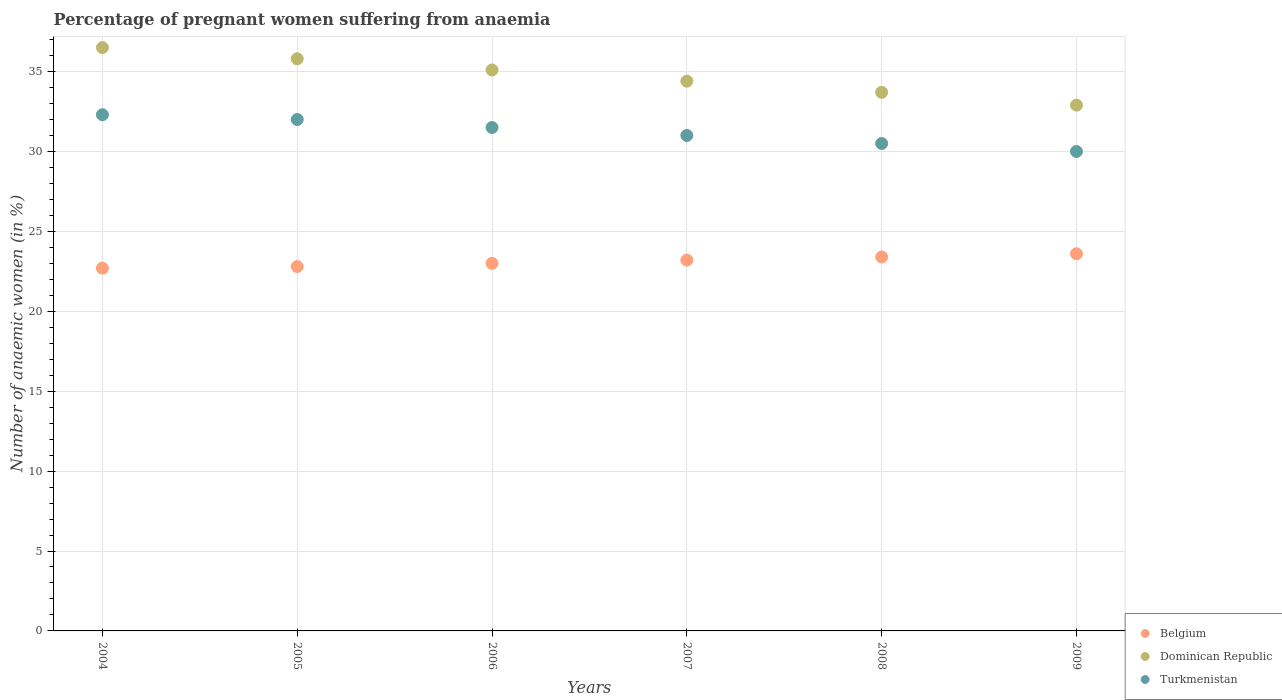How many different coloured dotlines are there?
Provide a succinct answer. 3. Is the number of dotlines equal to the number of legend labels?
Your answer should be very brief. Yes. What is the number of anaemic women in Belgium in 2009?
Ensure brevity in your answer.  23.6. Across all years, what is the maximum number of anaemic women in Belgium?
Offer a terse response. 23.6. Across all years, what is the minimum number of anaemic women in Dominican Republic?
Make the answer very short. 32.9. In which year was the number of anaemic women in Belgium minimum?
Provide a short and direct response. 2004. What is the total number of anaemic women in Turkmenistan in the graph?
Offer a terse response. 187.3. What is the difference between the number of anaemic women in Turkmenistan in 2006 and the number of anaemic women in Dominican Republic in 2005?
Your answer should be very brief. -4.3. What is the average number of anaemic women in Turkmenistan per year?
Your answer should be very brief. 31.22. In the year 2007, what is the difference between the number of anaemic women in Dominican Republic and number of anaemic women in Turkmenistan?
Keep it short and to the point. 3.4. What is the ratio of the number of anaemic women in Dominican Republic in 2005 to that in 2007?
Make the answer very short. 1.04. What is the difference between the highest and the second highest number of anaemic women in Turkmenistan?
Keep it short and to the point. 0.3. What is the difference between the highest and the lowest number of anaemic women in Belgium?
Make the answer very short. 0.9. In how many years, is the number of anaemic women in Turkmenistan greater than the average number of anaemic women in Turkmenistan taken over all years?
Your response must be concise. 3. Is the number of anaemic women in Dominican Republic strictly greater than the number of anaemic women in Turkmenistan over the years?
Ensure brevity in your answer.  Yes. How many dotlines are there?
Keep it short and to the point. 3. Does the graph contain grids?
Give a very brief answer. Yes. How many legend labels are there?
Provide a short and direct response. 3. How are the legend labels stacked?
Give a very brief answer. Vertical. What is the title of the graph?
Provide a succinct answer. Percentage of pregnant women suffering from anaemia. What is the label or title of the X-axis?
Ensure brevity in your answer.  Years. What is the label or title of the Y-axis?
Offer a very short reply. Number of anaemic women (in %). What is the Number of anaemic women (in %) in Belgium in 2004?
Your response must be concise. 22.7. What is the Number of anaemic women (in %) in Dominican Republic in 2004?
Keep it short and to the point. 36.5. What is the Number of anaemic women (in %) of Turkmenistan in 2004?
Your response must be concise. 32.3. What is the Number of anaemic women (in %) of Belgium in 2005?
Provide a short and direct response. 22.8. What is the Number of anaemic women (in %) of Dominican Republic in 2005?
Offer a terse response. 35.8. What is the Number of anaemic women (in %) in Dominican Republic in 2006?
Your answer should be very brief. 35.1. What is the Number of anaemic women (in %) of Turkmenistan in 2006?
Offer a terse response. 31.5. What is the Number of anaemic women (in %) of Belgium in 2007?
Give a very brief answer. 23.2. What is the Number of anaemic women (in %) of Dominican Republic in 2007?
Your answer should be very brief. 34.4. What is the Number of anaemic women (in %) in Belgium in 2008?
Your answer should be very brief. 23.4. What is the Number of anaemic women (in %) in Dominican Republic in 2008?
Offer a terse response. 33.7. What is the Number of anaemic women (in %) of Turkmenistan in 2008?
Keep it short and to the point. 30.5. What is the Number of anaemic women (in %) of Belgium in 2009?
Ensure brevity in your answer.  23.6. What is the Number of anaemic women (in %) of Dominican Republic in 2009?
Make the answer very short. 32.9. Across all years, what is the maximum Number of anaemic women (in %) in Belgium?
Your answer should be compact. 23.6. Across all years, what is the maximum Number of anaemic women (in %) in Dominican Republic?
Your answer should be compact. 36.5. Across all years, what is the maximum Number of anaemic women (in %) in Turkmenistan?
Ensure brevity in your answer.  32.3. Across all years, what is the minimum Number of anaemic women (in %) of Belgium?
Offer a terse response. 22.7. Across all years, what is the minimum Number of anaemic women (in %) in Dominican Republic?
Offer a terse response. 32.9. What is the total Number of anaemic women (in %) in Belgium in the graph?
Offer a terse response. 138.7. What is the total Number of anaemic women (in %) of Dominican Republic in the graph?
Provide a short and direct response. 208.4. What is the total Number of anaemic women (in %) in Turkmenistan in the graph?
Provide a succinct answer. 187.3. What is the difference between the Number of anaemic women (in %) of Dominican Republic in 2004 and that in 2005?
Your answer should be very brief. 0.7. What is the difference between the Number of anaemic women (in %) in Turkmenistan in 2004 and that in 2005?
Offer a terse response. 0.3. What is the difference between the Number of anaemic women (in %) of Belgium in 2004 and that in 2006?
Give a very brief answer. -0.3. What is the difference between the Number of anaemic women (in %) of Turkmenistan in 2004 and that in 2006?
Make the answer very short. 0.8. What is the difference between the Number of anaemic women (in %) of Dominican Republic in 2004 and that in 2007?
Provide a short and direct response. 2.1. What is the difference between the Number of anaemic women (in %) in Turkmenistan in 2004 and that in 2007?
Give a very brief answer. 1.3. What is the difference between the Number of anaemic women (in %) of Belgium in 2004 and that in 2008?
Ensure brevity in your answer.  -0.7. What is the difference between the Number of anaemic women (in %) in Dominican Republic in 2004 and that in 2008?
Provide a short and direct response. 2.8. What is the difference between the Number of anaemic women (in %) of Turkmenistan in 2004 and that in 2008?
Provide a short and direct response. 1.8. What is the difference between the Number of anaemic women (in %) in Dominican Republic in 2004 and that in 2009?
Ensure brevity in your answer.  3.6. What is the difference between the Number of anaemic women (in %) of Dominican Republic in 2005 and that in 2006?
Give a very brief answer. 0.7. What is the difference between the Number of anaemic women (in %) of Turkmenistan in 2005 and that in 2006?
Keep it short and to the point. 0.5. What is the difference between the Number of anaemic women (in %) in Turkmenistan in 2005 and that in 2007?
Provide a short and direct response. 1. What is the difference between the Number of anaemic women (in %) in Belgium in 2005 and that in 2008?
Offer a very short reply. -0.6. What is the difference between the Number of anaemic women (in %) of Dominican Republic in 2005 and that in 2008?
Your answer should be compact. 2.1. What is the difference between the Number of anaemic women (in %) in Turkmenistan in 2005 and that in 2008?
Offer a very short reply. 1.5. What is the difference between the Number of anaemic women (in %) in Belgium in 2005 and that in 2009?
Give a very brief answer. -0.8. What is the difference between the Number of anaemic women (in %) of Dominican Republic in 2005 and that in 2009?
Provide a short and direct response. 2.9. What is the difference between the Number of anaemic women (in %) of Belgium in 2006 and that in 2007?
Provide a succinct answer. -0.2. What is the difference between the Number of anaemic women (in %) of Turkmenistan in 2006 and that in 2007?
Ensure brevity in your answer.  0.5. What is the difference between the Number of anaemic women (in %) of Dominican Republic in 2006 and that in 2008?
Give a very brief answer. 1.4. What is the difference between the Number of anaemic women (in %) in Belgium in 2006 and that in 2009?
Your answer should be very brief. -0.6. What is the difference between the Number of anaemic women (in %) of Dominican Republic in 2006 and that in 2009?
Give a very brief answer. 2.2. What is the difference between the Number of anaemic women (in %) of Turkmenistan in 2006 and that in 2009?
Your answer should be very brief. 1.5. What is the difference between the Number of anaemic women (in %) of Dominican Republic in 2007 and that in 2008?
Your answer should be very brief. 0.7. What is the difference between the Number of anaemic women (in %) in Turkmenistan in 2007 and that in 2008?
Give a very brief answer. 0.5. What is the difference between the Number of anaemic women (in %) of Belgium in 2007 and that in 2009?
Your answer should be compact. -0.4. What is the difference between the Number of anaemic women (in %) of Turkmenistan in 2007 and that in 2009?
Keep it short and to the point. 1. What is the difference between the Number of anaemic women (in %) of Belgium in 2008 and that in 2009?
Provide a succinct answer. -0.2. What is the difference between the Number of anaemic women (in %) of Dominican Republic in 2008 and that in 2009?
Offer a very short reply. 0.8. What is the difference between the Number of anaemic women (in %) in Dominican Republic in 2004 and the Number of anaemic women (in %) in Turkmenistan in 2006?
Your answer should be very brief. 5. What is the difference between the Number of anaemic women (in %) of Belgium in 2004 and the Number of anaemic women (in %) of Turkmenistan in 2007?
Your response must be concise. -8.3. What is the difference between the Number of anaemic women (in %) in Dominican Republic in 2004 and the Number of anaemic women (in %) in Turkmenistan in 2007?
Make the answer very short. 5.5. What is the difference between the Number of anaemic women (in %) in Belgium in 2004 and the Number of anaemic women (in %) in Turkmenistan in 2008?
Provide a succinct answer. -7.8. What is the difference between the Number of anaemic women (in %) of Dominican Republic in 2004 and the Number of anaemic women (in %) of Turkmenistan in 2008?
Give a very brief answer. 6. What is the difference between the Number of anaemic women (in %) in Belgium in 2004 and the Number of anaemic women (in %) in Turkmenistan in 2009?
Your response must be concise. -7.3. What is the difference between the Number of anaemic women (in %) in Belgium in 2005 and the Number of anaemic women (in %) in Dominican Republic in 2006?
Your answer should be compact. -12.3. What is the difference between the Number of anaemic women (in %) of Belgium in 2005 and the Number of anaemic women (in %) of Turkmenistan in 2006?
Provide a short and direct response. -8.7. What is the difference between the Number of anaemic women (in %) of Belgium in 2005 and the Number of anaemic women (in %) of Turkmenistan in 2007?
Ensure brevity in your answer.  -8.2. What is the difference between the Number of anaemic women (in %) in Dominican Republic in 2005 and the Number of anaemic women (in %) in Turkmenistan in 2008?
Make the answer very short. 5.3. What is the difference between the Number of anaemic women (in %) in Belgium in 2005 and the Number of anaemic women (in %) in Dominican Republic in 2009?
Offer a very short reply. -10.1. What is the difference between the Number of anaemic women (in %) of Belgium in 2005 and the Number of anaemic women (in %) of Turkmenistan in 2009?
Your answer should be very brief. -7.2. What is the difference between the Number of anaemic women (in %) of Dominican Republic in 2005 and the Number of anaemic women (in %) of Turkmenistan in 2009?
Make the answer very short. 5.8. What is the difference between the Number of anaemic women (in %) of Belgium in 2006 and the Number of anaemic women (in %) of Dominican Republic in 2007?
Provide a short and direct response. -11.4. What is the difference between the Number of anaemic women (in %) of Belgium in 2006 and the Number of anaemic women (in %) of Dominican Republic in 2008?
Your answer should be compact. -10.7. What is the difference between the Number of anaemic women (in %) in Belgium in 2006 and the Number of anaemic women (in %) in Turkmenistan in 2008?
Make the answer very short. -7.5. What is the difference between the Number of anaemic women (in %) in Dominican Republic in 2006 and the Number of anaemic women (in %) in Turkmenistan in 2009?
Offer a terse response. 5.1. What is the difference between the Number of anaemic women (in %) of Dominican Republic in 2007 and the Number of anaemic women (in %) of Turkmenistan in 2008?
Offer a very short reply. 3.9. What is the difference between the Number of anaemic women (in %) of Belgium in 2007 and the Number of anaemic women (in %) of Dominican Republic in 2009?
Keep it short and to the point. -9.7. What is the difference between the Number of anaemic women (in %) in Belgium in 2007 and the Number of anaemic women (in %) in Turkmenistan in 2009?
Provide a succinct answer. -6.8. What is the difference between the Number of anaemic women (in %) in Dominican Republic in 2007 and the Number of anaemic women (in %) in Turkmenistan in 2009?
Your response must be concise. 4.4. What is the difference between the Number of anaemic women (in %) of Belgium in 2008 and the Number of anaemic women (in %) of Turkmenistan in 2009?
Your answer should be compact. -6.6. What is the difference between the Number of anaemic women (in %) in Dominican Republic in 2008 and the Number of anaemic women (in %) in Turkmenistan in 2009?
Keep it short and to the point. 3.7. What is the average Number of anaemic women (in %) in Belgium per year?
Ensure brevity in your answer.  23.12. What is the average Number of anaemic women (in %) in Dominican Republic per year?
Your answer should be very brief. 34.73. What is the average Number of anaemic women (in %) in Turkmenistan per year?
Make the answer very short. 31.22. In the year 2004, what is the difference between the Number of anaemic women (in %) of Belgium and Number of anaemic women (in %) of Dominican Republic?
Give a very brief answer. -13.8. In the year 2004, what is the difference between the Number of anaemic women (in %) in Belgium and Number of anaemic women (in %) in Turkmenistan?
Provide a succinct answer. -9.6. In the year 2004, what is the difference between the Number of anaemic women (in %) of Dominican Republic and Number of anaemic women (in %) of Turkmenistan?
Provide a succinct answer. 4.2. In the year 2005, what is the difference between the Number of anaemic women (in %) of Belgium and Number of anaemic women (in %) of Dominican Republic?
Provide a succinct answer. -13. In the year 2006, what is the difference between the Number of anaemic women (in %) of Belgium and Number of anaemic women (in %) of Dominican Republic?
Your answer should be compact. -12.1. In the year 2006, what is the difference between the Number of anaemic women (in %) in Dominican Republic and Number of anaemic women (in %) in Turkmenistan?
Ensure brevity in your answer.  3.6. In the year 2007, what is the difference between the Number of anaemic women (in %) of Belgium and Number of anaemic women (in %) of Dominican Republic?
Your response must be concise. -11.2. In the year 2007, what is the difference between the Number of anaemic women (in %) in Dominican Republic and Number of anaemic women (in %) in Turkmenistan?
Provide a short and direct response. 3.4. In the year 2008, what is the difference between the Number of anaemic women (in %) of Dominican Republic and Number of anaemic women (in %) of Turkmenistan?
Your response must be concise. 3.2. In the year 2009, what is the difference between the Number of anaemic women (in %) in Dominican Republic and Number of anaemic women (in %) in Turkmenistan?
Give a very brief answer. 2.9. What is the ratio of the Number of anaemic women (in %) of Dominican Republic in 2004 to that in 2005?
Give a very brief answer. 1.02. What is the ratio of the Number of anaemic women (in %) in Turkmenistan in 2004 to that in 2005?
Keep it short and to the point. 1.01. What is the ratio of the Number of anaemic women (in %) in Belgium in 2004 to that in 2006?
Provide a short and direct response. 0.99. What is the ratio of the Number of anaemic women (in %) of Dominican Republic in 2004 to that in 2006?
Provide a succinct answer. 1.04. What is the ratio of the Number of anaemic women (in %) in Turkmenistan in 2004 to that in 2006?
Keep it short and to the point. 1.03. What is the ratio of the Number of anaemic women (in %) of Belgium in 2004 to that in 2007?
Provide a short and direct response. 0.98. What is the ratio of the Number of anaemic women (in %) in Dominican Republic in 2004 to that in 2007?
Your answer should be very brief. 1.06. What is the ratio of the Number of anaemic women (in %) of Turkmenistan in 2004 to that in 2007?
Provide a succinct answer. 1.04. What is the ratio of the Number of anaemic women (in %) of Belgium in 2004 to that in 2008?
Provide a succinct answer. 0.97. What is the ratio of the Number of anaemic women (in %) of Dominican Republic in 2004 to that in 2008?
Provide a succinct answer. 1.08. What is the ratio of the Number of anaemic women (in %) in Turkmenistan in 2004 to that in 2008?
Provide a succinct answer. 1.06. What is the ratio of the Number of anaemic women (in %) of Belgium in 2004 to that in 2009?
Keep it short and to the point. 0.96. What is the ratio of the Number of anaemic women (in %) in Dominican Republic in 2004 to that in 2009?
Provide a short and direct response. 1.11. What is the ratio of the Number of anaemic women (in %) of Turkmenistan in 2004 to that in 2009?
Provide a short and direct response. 1.08. What is the ratio of the Number of anaemic women (in %) of Belgium in 2005 to that in 2006?
Offer a very short reply. 0.99. What is the ratio of the Number of anaemic women (in %) in Dominican Republic in 2005 to that in 2006?
Provide a succinct answer. 1.02. What is the ratio of the Number of anaemic women (in %) in Turkmenistan in 2005 to that in 2006?
Give a very brief answer. 1.02. What is the ratio of the Number of anaemic women (in %) of Belgium in 2005 to that in 2007?
Your answer should be compact. 0.98. What is the ratio of the Number of anaemic women (in %) in Dominican Republic in 2005 to that in 2007?
Your response must be concise. 1.04. What is the ratio of the Number of anaemic women (in %) of Turkmenistan in 2005 to that in 2007?
Offer a very short reply. 1.03. What is the ratio of the Number of anaemic women (in %) of Belgium in 2005 to that in 2008?
Offer a terse response. 0.97. What is the ratio of the Number of anaemic women (in %) of Dominican Republic in 2005 to that in 2008?
Your answer should be compact. 1.06. What is the ratio of the Number of anaemic women (in %) in Turkmenistan in 2005 to that in 2008?
Give a very brief answer. 1.05. What is the ratio of the Number of anaemic women (in %) of Belgium in 2005 to that in 2009?
Offer a very short reply. 0.97. What is the ratio of the Number of anaemic women (in %) of Dominican Republic in 2005 to that in 2009?
Your response must be concise. 1.09. What is the ratio of the Number of anaemic women (in %) in Turkmenistan in 2005 to that in 2009?
Keep it short and to the point. 1.07. What is the ratio of the Number of anaemic women (in %) in Belgium in 2006 to that in 2007?
Provide a short and direct response. 0.99. What is the ratio of the Number of anaemic women (in %) of Dominican Republic in 2006 to that in 2007?
Your answer should be compact. 1.02. What is the ratio of the Number of anaemic women (in %) of Turkmenistan in 2006 to that in 2007?
Make the answer very short. 1.02. What is the ratio of the Number of anaemic women (in %) in Belgium in 2006 to that in 2008?
Your response must be concise. 0.98. What is the ratio of the Number of anaemic women (in %) in Dominican Republic in 2006 to that in 2008?
Keep it short and to the point. 1.04. What is the ratio of the Number of anaemic women (in %) in Turkmenistan in 2006 to that in 2008?
Give a very brief answer. 1.03. What is the ratio of the Number of anaemic women (in %) of Belgium in 2006 to that in 2009?
Provide a short and direct response. 0.97. What is the ratio of the Number of anaemic women (in %) in Dominican Republic in 2006 to that in 2009?
Offer a terse response. 1.07. What is the ratio of the Number of anaemic women (in %) of Belgium in 2007 to that in 2008?
Make the answer very short. 0.99. What is the ratio of the Number of anaemic women (in %) of Dominican Republic in 2007 to that in 2008?
Provide a short and direct response. 1.02. What is the ratio of the Number of anaemic women (in %) of Turkmenistan in 2007 to that in 2008?
Keep it short and to the point. 1.02. What is the ratio of the Number of anaemic women (in %) in Belgium in 2007 to that in 2009?
Make the answer very short. 0.98. What is the ratio of the Number of anaemic women (in %) of Dominican Republic in 2007 to that in 2009?
Offer a terse response. 1.05. What is the ratio of the Number of anaemic women (in %) of Turkmenistan in 2007 to that in 2009?
Provide a succinct answer. 1.03. What is the ratio of the Number of anaemic women (in %) in Dominican Republic in 2008 to that in 2009?
Your answer should be compact. 1.02. What is the ratio of the Number of anaemic women (in %) of Turkmenistan in 2008 to that in 2009?
Keep it short and to the point. 1.02. What is the difference between the highest and the second highest Number of anaemic women (in %) in Dominican Republic?
Keep it short and to the point. 0.7. What is the difference between the highest and the lowest Number of anaemic women (in %) in Belgium?
Provide a succinct answer. 0.9. What is the difference between the highest and the lowest Number of anaemic women (in %) in Dominican Republic?
Keep it short and to the point. 3.6. What is the difference between the highest and the lowest Number of anaemic women (in %) of Turkmenistan?
Your answer should be very brief. 2.3. 